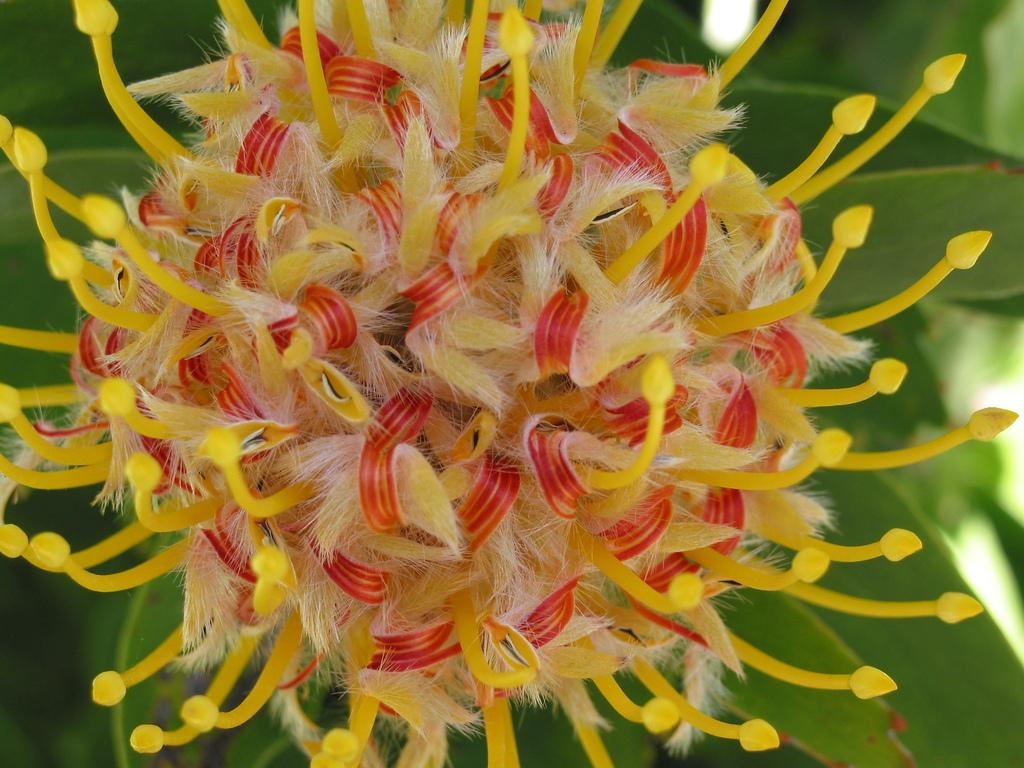What type of plant is visible in the image? There is a flower in the image. What colors can be seen on the flower? The flower has yellow, red, and cream colors. What other plant-related object is present in the image? There is a plant in the image. What color is the plant? The plant is green in color. What month is depicted in the image? There is no month depicted in the image; it features a flower and a plant. What type of instrument is being played in the image? There is no instrument present in the image; it features a flower and a plant. 